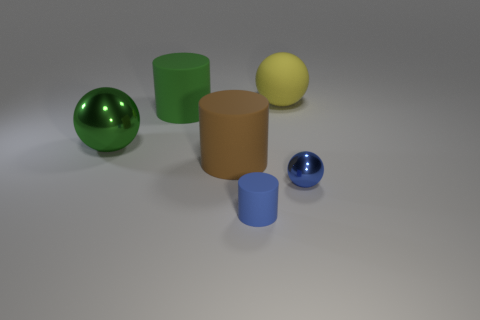Add 2 tiny purple matte cylinders. How many objects exist? 8 Subtract 3 cylinders. How many cylinders are left? 0 Subtract all large green metal balls. How many balls are left? 2 Subtract all tiny blue balls. Subtract all large rubber cylinders. How many objects are left? 3 Add 1 green rubber objects. How many green rubber objects are left? 2 Add 1 small gray metal objects. How many small gray metal objects exist? 1 Subtract all blue balls. How many balls are left? 2 Subtract 0 yellow cylinders. How many objects are left? 6 Subtract all red cylinders. Subtract all purple cubes. How many cylinders are left? 3 Subtract all brown cylinders. How many green balls are left? 1 